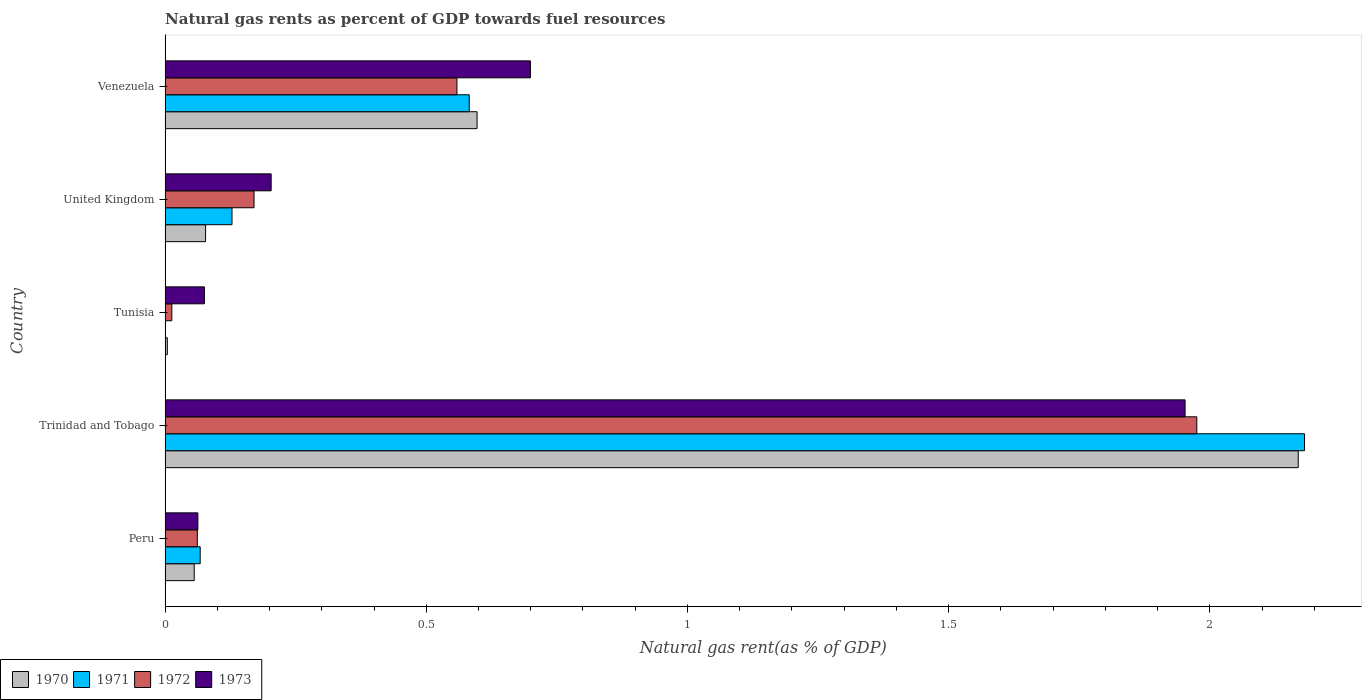Are the number of bars on each tick of the Y-axis equal?
Your answer should be very brief. Yes. What is the label of the 4th group of bars from the top?
Ensure brevity in your answer.  Trinidad and Tobago. In how many cases, is the number of bars for a given country not equal to the number of legend labels?
Provide a short and direct response. 0. What is the natural gas rent in 1971 in Peru?
Keep it short and to the point. 0.07. Across all countries, what is the maximum natural gas rent in 1971?
Your answer should be very brief. 2.18. Across all countries, what is the minimum natural gas rent in 1971?
Give a very brief answer. 0. In which country was the natural gas rent in 1971 maximum?
Provide a short and direct response. Trinidad and Tobago. In which country was the natural gas rent in 1971 minimum?
Your response must be concise. Tunisia. What is the total natural gas rent in 1971 in the graph?
Your answer should be compact. 2.96. What is the difference between the natural gas rent in 1971 in Peru and that in United Kingdom?
Ensure brevity in your answer.  -0.06. What is the difference between the natural gas rent in 1972 in Venezuela and the natural gas rent in 1973 in United Kingdom?
Provide a succinct answer. 0.36. What is the average natural gas rent in 1970 per country?
Provide a short and direct response. 0.58. What is the difference between the natural gas rent in 1973 and natural gas rent in 1970 in Venezuela?
Make the answer very short. 0.1. In how many countries, is the natural gas rent in 1971 greater than 0.9 %?
Give a very brief answer. 1. What is the ratio of the natural gas rent in 1973 in Peru to that in United Kingdom?
Make the answer very short. 0.31. Is the difference between the natural gas rent in 1973 in Peru and United Kingdom greater than the difference between the natural gas rent in 1970 in Peru and United Kingdom?
Provide a short and direct response. No. What is the difference between the highest and the second highest natural gas rent in 1973?
Offer a very short reply. 1.25. What is the difference between the highest and the lowest natural gas rent in 1973?
Your answer should be very brief. 1.89. In how many countries, is the natural gas rent in 1971 greater than the average natural gas rent in 1971 taken over all countries?
Your response must be concise. 1. What does the 1st bar from the top in Peru represents?
Keep it short and to the point. 1973. Is it the case that in every country, the sum of the natural gas rent in 1971 and natural gas rent in 1970 is greater than the natural gas rent in 1972?
Keep it short and to the point. No. How many bars are there?
Make the answer very short. 20. How many countries are there in the graph?
Offer a terse response. 5. What is the difference between two consecutive major ticks on the X-axis?
Ensure brevity in your answer.  0.5. Does the graph contain any zero values?
Your response must be concise. No. What is the title of the graph?
Give a very brief answer. Natural gas rents as percent of GDP towards fuel resources. Does "1973" appear as one of the legend labels in the graph?
Your answer should be very brief. Yes. What is the label or title of the X-axis?
Your answer should be compact. Natural gas rent(as % of GDP). What is the label or title of the Y-axis?
Provide a succinct answer. Country. What is the Natural gas rent(as % of GDP) in 1970 in Peru?
Offer a very short reply. 0.06. What is the Natural gas rent(as % of GDP) of 1971 in Peru?
Provide a succinct answer. 0.07. What is the Natural gas rent(as % of GDP) in 1972 in Peru?
Ensure brevity in your answer.  0.06. What is the Natural gas rent(as % of GDP) of 1973 in Peru?
Your answer should be very brief. 0.06. What is the Natural gas rent(as % of GDP) in 1970 in Trinidad and Tobago?
Give a very brief answer. 2.17. What is the Natural gas rent(as % of GDP) of 1971 in Trinidad and Tobago?
Offer a very short reply. 2.18. What is the Natural gas rent(as % of GDP) in 1972 in Trinidad and Tobago?
Provide a short and direct response. 1.98. What is the Natural gas rent(as % of GDP) in 1973 in Trinidad and Tobago?
Make the answer very short. 1.95. What is the Natural gas rent(as % of GDP) in 1970 in Tunisia?
Give a very brief answer. 0. What is the Natural gas rent(as % of GDP) in 1971 in Tunisia?
Keep it short and to the point. 0. What is the Natural gas rent(as % of GDP) in 1972 in Tunisia?
Make the answer very short. 0.01. What is the Natural gas rent(as % of GDP) of 1973 in Tunisia?
Provide a succinct answer. 0.08. What is the Natural gas rent(as % of GDP) in 1970 in United Kingdom?
Make the answer very short. 0.08. What is the Natural gas rent(as % of GDP) in 1971 in United Kingdom?
Provide a short and direct response. 0.13. What is the Natural gas rent(as % of GDP) in 1972 in United Kingdom?
Provide a succinct answer. 0.17. What is the Natural gas rent(as % of GDP) in 1973 in United Kingdom?
Make the answer very short. 0.2. What is the Natural gas rent(as % of GDP) of 1970 in Venezuela?
Give a very brief answer. 0.6. What is the Natural gas rent(as % of GDP) in 1971 in Venezuela?
Give a very brief answer. 0.58. What is the Natural gas rent(as % of GDP) in 1972 in Venezuela?
Offer a terse response. 0.56. What is the Natural gas rent(as % of GDP) of 1973 in Venezuela?
Offer a very short reply. 0.7. Across all countries, what is the maximum Natural gas rent(as % of GDP) of 1970?
Ensure brevity in your answer.  2.17. Across all countries, what is the maximum Natural gas rent(as % of GDP) of 1971?
Provide a short and direct response. 2.18. Across all countries, what is the maximum Natural gas rent(as % of GDP) in 1972?
Offer a very short reply. 1.98. Across all countries, what is the maximum Natural gas rent(as % of GDP) in 1973?
Your answer should be very brief. 1.95. Across all countries, what is the minimum Natural gas rent(as % of GDP) of 1970?
Make the answer very short. 0. Across all countries, what is the minimum Natural gas rent(as % of GDP) in 1971?
Your response must be concise. 0. Across all countries, what is the minimum Natural gas rent(as % of GDP) of 1972?
Give a very brief answer. 0.01. Across all countries, what is the minimum Natural gas rent(as % of GDP) of 1973?
Keep it short and to the point. 0.06. What is the total Natural gas rent(as % of GDP) in 1970 in the graph?
Give a very brief answer. 2.9. What is the total Natural gas rent(as % of GDP) in 1971 in the graph?
Give a very brief answer. 2.96. What is the total Natural gas rent(as % of GDP) of 1972 in the graph?
Your answer should be compact. 2.78. What is the total Natural gas rent(as % of GDP) of 1973 in the graph?
Make the answer very short. 2.99. What is the difference between the Natural gas rent(as % of GDP) in 1970 in Peru and that in Trinidad and Tobago?
Your answer should be compact. -2.11. What is the difference between the Natural gas rent(as % of GDP) of 1971 in Peru and that in Trinidad and Tobago?
Ensure brevity in your answer.  -2.11. What is the difference between the Natural gas rent(as % of GDP) in 1972 in Peru and that in Trinidad and Tobago?
Your response must be concise. -1.91. What is the difference between the Natural gas rent(as % of GDP) in 1973 in Peru and that in Trinidad and Tobago?
Provide a short and direct response. -1.89. What is the difference between the Natural gas rent(as % of GDP) of 1970 in Peru and that in Tunisia?
Keep it short and to the point. 0.05. What is the difference between the Natural gas rent(as % of GDP) of 1971 in Peru and that in Tunisia?
Provide a short and direct response. 0.07. What is the difference between the Natural gas rent(as % of GDP) in 1972 in Peru and that in Tunisia?
Provide a short and direct response. 0.05. What is the difference between the Natural gas rent(as % of GDP) in 1973 in Peru and that in Tunisia?
Ensure brevity in your answer.  -0.01. What is the difference between the Natural gas rent(as % of GDP) of 1970 in Peru and that in United Kingdom?
Your answer should be compact. -0.02. What is the difference between the Natural gas rent(as % of GDP) in 1971 in Peru and that in United Kingdom?
Provide a short and direct response. -0.06. What is the difference between the Natural gas rent(as % of GDP) of 1972 in Peru and that in United Kingdom?
Provide a succinct answer. -0.11. What is the difference between the Natural gas rent(as % of GDP) of 1973 in Peru and that in United Kingdom?
Provide a short and direct response. -0.14. What is the difference between the Natural gas rent(as % of GDP) of 1970 in Peru and that in Venezuela?
Provide a short and direct response. -0.54. What is the difference between the Natural gas rent(as % of GDP) of 1971 in Peru and that in Venezuela?
Offer a very short reply. -0.52. What is the difference between the Natural gas rent(as % of GDP) in 1972 in Peru and that in Venezuela?
Give a very brief answer. -0.5. What is the difference between the Natural gas rent(as % of GDP) in 1973 in Peru and that in Venezuela?
Provide a short and direct response. -0.64. What is the difference between the Natural gas rent(as % of GDP) in 1970 in Trinidad and Tobago and that in Tunisia?
Make the answer very short. 2.17. What is the difference between the Natural gas rent(as % of GDP) of 1971 in Trinidad and Tobago and that in Tunisia?
Ensure brevity in your answer.  2.18. What is the difference between the Natural gas rent(as % of GDP) in 1972 in Trinidad and Tobago and that in Tunisia?
Ensure brevity in your answer.  1.96. What is the difference between the Natural gas rent(as % of GDP) of 1973 in Trinidad and Tobago and that in Tunisia?
Your response must be concise. 1.88. What is the difference between the Natural gas rent(as % of GDP) in 1970 in Trinidad and Tobago and that in United Kingdom?
Offer a terse response. 2.09. What is the difference between the Natural gas rent(as % of GDP) of 1971 in Trinidad and Tobago and that in United Kingdom?
Your answer should be very brief. 2.05. What is the difference between the Natural gas rent(as % of GDP) in 1972 in Trinidad and Tobago and that in United Kingdom?
Ensure brevity in your answer.  1.8. What is the difference between the Natural gas rent(as % of GDP) in 1973 in Trinidad and Tobago and that in United Kingdom?
Your response must be concise. 1.75. What is the difference between the Natural gas rent(as % of GDP) of 1970 in Trinidad and Tobago and that in Venezuela?
Your answer should be compact. 1.57. What is the difference between the Natural gas rent(as % of GDP) in 1971 in Trinidad and Tobago and that in Venezuela?
Provide a succinct answer. 1.6. What is the difference between the Natural gas rent(as % of GDP) in 1972 in Trinidad and Tobago and that in Venezuela?
Keep it short and to the point. 1.42. What is the difference between the Natural gas rent(as % of GDP) in 1973 in Trinidad and Tobago and that in Venezuela?
Offer a terse response. 1.25. What is the difference between the Natural gas rent(as % of GDP) in 1970 in Tunisia and that in United Kingdom?
Your answer should be compact. -0.07. What is the difference between the Natural gas rent(as % of GDP) of 1971 in Tunisia and that in United Kingdom?
Make the answer very short. -0.13. What is the difference between the Natural gas rent(as % of GDP) in 1972 in Tunisia and that in United Kingdom?
Ensure brevity in your answer.  -0.16. What is the difference between the Natural gas rent(as % of GDP) of 1973 in Tunisia and that in United Kingdom?
Keep it short and to the point. -0.13. What is the difference between the Natural gas rent(as % of GDP) in 1970 in Tunisia and that in Venezuela?
Ensure brevity in your answer.  -0.59. What is the difference between the Natural gas rent(as % of GDP) of 1971 in Tunisia and that in Venezuela?
Your answer should be very brief. -0.58. What is the difference between the Natural gas rent(as % of GDP) in 1972 in Tunisia and that in Venezuela?
Your answer should be very brief. -0.55. What is the difference between the Natural gas rent(as % of GDP) in 1973 in Tunisia and that in Venezuela?
Give a very brief answer. -0.62. What is the difference between the Natural gas rent(as % of GDP) in 1970 in United Kingdom and that in Venezuela?
Offer a very short reply. -0.52. What is the difference between the Natural gas rent(as % of GDP) of 1971 in United Kingdom and that in Venezuela?
Provide a short and direct response. -0.45. What is the difference between the Natural gas rent(as % of GDP) of 1972 in United Kingdom and that in Venezuela?
Offer a very short reply. -0.39. What is the difference between the Natural gas rent(as % of GDP) in 1973 in United Kingdom and that in Venezuela?
Your response must be concise. -0.5. What is the difference between the Natural gas rent(as % of GDP) in 1970 in Peru and the Natural gas rent(as % of GDP) in 1971 in Trinidad and Tobago?
Your response must be concise. -2.13. What is the difference between the Natural gas rent(as % of GDP) of 1970 in Peru and the Natural gas rent(as % of GDP) of 1972 in Trinidad and Tobago?
Your response must be concise. -1.92. What is the difference between the Natural gas rent(as % of GDP) in 1970 in Peru and the Natural gas rent(as % of GDP) in 1973 in Trinidad and Tobago?
Make the answer very short. -1.9. What is the difference between the Natural gas rent(as % of GDP) in 1971 in Peru and the Natural gas rent(as % of GDP) in 1972 in Trinidad and Tobago?
Your answer should be compact. -1.91. What is the difference between the Natural gas rent(as % of GDP) of 1971 in Peru and the Natural gas rent(as % of GDP) of 1973 in Trinidad and Tobago?
Ensure brevity in your answer.  -1.89. What is the difference between the Natural gas rent(as % of GDP) of 1972 in Peru and the Natural gas rent(as % of GDP) of 1973 in Trinidad and Tobago?
Your response must be concise. -1.89. What is the difference between the Natural gas rent(as % of GDP) in 1970 in Peru and the Natural gas rent(as % of GDP) in 1971 in Tunisia?
Provide a succinct answer. 0.06. What is the difference between the Natural gas rent(as % of GDP) in 1970 in Peru and the Natural gas rent(as % of GDP) in 1972 in Tunisia?
Give a very brief answer. 0.04. What is the difference between the Natural gas rent(as % of GDP) in 1970 in Peru and the Natural gas rent(as % of GDP) in 1973 in Tunisia?
Offer a very short reply. -0.02. What is the difference between the Natural gas rent(as % of GDP) in 1971 in Peru and the Natural gas rent(as % of GDP) in 1972 in Tunisia?
Give a very brief answer. 0.05. What is the difference between the Natural gas rent(as % of GDP) of 1971 in Peru and the Natural gas rent(as % of GDP) of 1973 in Tunisia?
Offer a terse response. -0.01. What is the difference between the Natural gas rent(as % of GDP) in 1972 in Peru and the Natural gas rent(as % of GDP) in 1973 in Tunisia?
Ensure brevity in your answer.  -0.01. What is the difference between the Natural gas rent(as % of GDP) of 1970 in Peru and the Natural gas rent(as % of GDP) of 1971 in United Kingdom?
Provide a succinct answer. -0.07. What is the difference between the Natural gas rent(as % of GDP) of 1970 in Peru and the Natural gas rent(as % of GDP) of 1972 in United Kingdom?
Ensure brevity in your answer.  -0.11. What is the difference between the Natural gas rent(as % of GDP) of 1970 in Peru and the Natural gas rent(as % of GDP) of 1973 in United Kingdom?
Provide a short and direct response. -0.15. What is the difference between the Natural gas rent(as % of GDP) of 1971 in Peru and the Natural gas rent(as % of GDP) of 1972 in United Kingdom?
Offer a very short reply. -0.1. What is the difference between the Natural gas rent(as % of GDP) of 1971 in Peru and the Natural gas rent(as % of GDP) of 1973 in United Kingdom?
Offer a very short reply. -0.14. What is the difference between the Natural gas rent(as % of GDP) of 1972 in Peru and the Natural gas rent(as % of GDP) of 1973 in United Kingdom?
Your response must be concise. -0.14. What is the difference between the Natural gas rent(as % of GDP) of 1970 in Peru and the Natural gas rent(as % of GDP) of 1971 in Venezuela?
Your response must be concise. -0.53. What is the difference between the Natural gas rent(as % of GDP) of 1970 in Peru and the Natural gas rent(as % of GDP) of 1972 in Venezuela?
Keep it short and to the point. -0.5. What is the difference between the Natural gas rent(as % of GDP) in 1970 in Peru and the Natural gas rent(as % of GDP) in 1973 in Venezuela?
Offer a terse response. -0.64. What is the difference between the Natural gas rent(as % of GDP) of 1971 in Peru and the Natural gas rent(as % of GDP) of 1972 in Venezuela?
Your answer should be compact. -0.49. What is the difference between the Natural gas rent(as % of GDP) in 1971 in Peru and the Natural gas rent(as % of GDP) in 1973 in Venezuela?
Your answer should be very brief. -0.63. What is the difference between the Natural gas rent(as % of GDP) of 1972 in Peru and the Natural gas rent(as % of GDP) of 1973 in Venezuela?
Your answer should be very brief. -0.64. What is the difference between the Natural gas rent(as % of GDP) of 1970 in Trinidad and Tobago and the Natural gas rent(as % of GDP) of 1971 in Tunisia?
Your response must be concise. 2.17. What is the difference between the Natural gas rent(as % of GDP) of 1970 in Trinidad and Tobago and the Natural gas rent(as % of GDP) of 1972 in Tunisia?
Offer a very short reply. 2.16. What is the difference between the Natural gas rent(as % of GDP) of 1970 in Trinidad and Tobago and the Natural gas rent(as % of GDP) of 1973 in Tunisia?
Ensure brevity in your answer.  2.09. What is the difference between the Natural gas rent(as % of GDP) of 1971 in Trinidad and Tobago and the Natural gas rent(as % of GDP) of 1972 in Tunisia?
Offer a very short reply. 2.17. What is the difference between the Natural gas rent(as % of GDP) in 1971 in Trinidad and Tobago and the Natural gas rent(as % of GDP) in 1973 in Tunisia?
Your answer should be very brief. 2.11. What is the difference between the Natural gas rent(as % of GDP) in 1972 in Trinidad and Tobago and the Natural gas rent(as % of GDP) in 1973 in Tunisia?
Your answer should be compact. 1.9. What is the difference between the Natural gas rent(as % of GDP) of 1970 in Trinidad and Tobago and the Natural gas rent(as % of GDP) of 1971 in United Kingdom?
Ensure brevity in your answer.  2.04. What is the difference between the Natural gas rent(as % of GDP) of 1970 in Trinidad and Tobago and the Natural gas rent(as % of GDP) of 1972 in United Kingdom?
Offer a terse response. 2. What is the difference between the Natural gas rent(as % of GDP) of 1970 in Trinidad and Tobago and the Natural gas rent(as % of GDP) of 1973 in United Kingdom?
Ensure brevity in your answer.  1.97. What is the difference between the Natural gas rent(as % of GDP) of 1971 in Trinidad and Tobago and the Natural gas rent(as % of GDP) of 1972 in United Kingdom?
Provide a succinct answer. 2.01. What is the difference between the Natural gas rent(as % of GDP) in 1971 in Trinidad and Tobago and the Natural gas rent(as % of GDP) in 1973 in United Kingdom?
Offer a very short reply. 1.98. What is the difference between the Natural gas rent(as % of GDP) of 1972 in Trinidad and Tobago and the Natural gas rent(as % of GDP) of 1973 in United Kingdom?
Keep it short and to the point. 1.77. What is the difference between the Natural gas rent(as % of GDP) of 1970 in Trinidad and Tobago and the Natural gas rent(as % of GDP) of 1971 in Venezuela?
Give a very brief answer. 1.59. What is the difference between the Natural gas rent(as % of GDP) in 1970 in Trinidad and Tobago and the Natural gas rent(as % of GDP) in 1972 in Venezuela?
Your answer should be very brief. 1.61. What is the difference between the Natural gas rent(as % of GDP) of 1970 in Trinidad and Tobago and the Natural gas rent(as % of GDP) of 1973 in Venezuela?
Provide a short and direct response. 1.47. What is the difference between the Natural gas rent(as % of GDP) in 1971 in Trinidad and Tobago and the Natural gas rent(as % of GDP) in 1972 in Venezuela?
Ensure brevity in your answer.  1.62. What is the difference between the Natural gas rent(as % of GDP) in 1971 in Trinidad and Tobago and the Natural gas rent(as % of GDP) in 1973 in Venezuela?
Your answer should be very brief. 1.48. What is the difference between the Natural gas rent(as % of GDP) in 1972 in Trinidad and Tobago and the Natural gas rent(as % of GDP) in 1973 in Venezuela?
Your answer should be compact. 1.28. What is the difference between the Natural gas rent(as % of GDP) in 1970 in Tunisia and the Natural gas rent(as % of GDP) in 1971 in United Kingdom?
Your answer should be very brief. -0.12. What is the difference between the Natural gas rent(as % of GDP) of 1970 in Tunisia and the Natural gas rent(as % of GDP) of 1972 in United Kingdom?
Provide a short and direct response. -0.17. What is the difference between the Natural gas rent(as % of GDP) of 1970 in Tunisia and the Natural gas rent(as % of GDP) of 1973 in United Kingdom?
Ensure brevity in your answer.  -0.2. What is the difference between the Natural gas rent(as % of GDP) of 1971 in Tunisia and the Natural gas rent(as % of GDP) of 1972 in United Kingdom?
Your answer should be very brief. -0.17. What is the difference between the Natural gas rent(as % of GDP) of 1971 in Tunisia and the Natural gas rent(as % of GDP) of 1973 in United Kingdom?
Your answer should be very brief. -0.2. What is the difference between the Natural gas rent(as % of GDP) in 1972 in Tunisia and the Natural gas rent(as % of GDP) in 1973 in United Kingdom?
Keep it short and to the point. -0.19. What is the difference between the Natural gas rent(as % of GDP) in 1970 in Tunisia and the Natural gas rent(as % of GDP) in 1971 in Venezuela?
Provide a succinct answer. -0.58. What is the difference between the Natural gas rent(as % of GDP) in 1970 in Tunisia and the Natural gas rent(as % of GDP) in 1972 in Venezuela?
Your answer should be compact. -0.55. What is the difference between the Natural gas rent(as % of GDP) of 1970 in Tunisia and the Natural gas rent(as % of GDP) of 1973 in Venezuela?
Your answer should be very brief. -0.7. What is the difference between the Natural gas rent(as % of GDP) in 1971 in Tunisia and the Natural gas rent(as % of GDP) in 1972 in Venezuela?
Your answer should be compact. -0.56. What is the difference between the Natural gas rent(as % of GDP) in 1971 in Tunisia and the Natural gas rent(as % of GDP) in 1973 in Venezuela?
Your answer should be very brief. -0.7. What is the difference between the Natural gas rent(as % of GDP) in 1972 in Tunisia and the Natural gas rent(as % of GDP) in 1973 in Venezuela?
Give a very brief answer. -0.69. What is the difference between the Natural gas rent(as % of GDP) in 1970 in United Kingdom and the Natural gas rent(as % of GDP) in 1971 in Venezuela?
Ensure brevity in your answer.  -0.5. What is the difference between the Natural gas rent(as % of GDP) in 1970 in United Kingdom and the Natural gas rent(as % of GDP) in 1972 in Venezuela?
Your response must be concise. -0.48. What is the difference between the Natural gas rent(as % of GDP) in 1970 in United Kingdom and the Natural gas rent(as % of GDP) in 1973 in Venezuela?
Your answer should be compact. -0.62. What is the difference between the Natural gas rent(as % of GDP) of 1971 in United Kingdom and the Natural gas rent(as % of GDP) of 1972 in Venezuela?
Provide a short and direct response. -0.43. What is the difference between the Natural gas rent(as % of GDP) of 1971 in United Kingdom and the Natural gas rent(as % of GDP) of 1973 in Venezuela?
Provide a succinct answer. -0.57. What is the difference between the Natural gas rent(as % of GDP) in 1972 in United Kingdom and the Natural gas rent(as % of GDP) in 1973 in Venezuela?
Your answer should be very brief. -0.53. What is the average Natural gas rent(as % of GDP) of 1970 per country?
Make the answer very short. 0.58. What is the average Natural gas rent(as % of GDP) in 1971 per country?
Your answer should be very brief. 0.59. What is the average Natural gas rent(as % of GDP) in 1972 per country?
Provide a short and direct response. 0.56. What is the average Natural gas rent(as % of GDP) in 1973 per country?
Give a very brief answer. 0.6. What is the difference between the Natural gas rent(as % of GDP) in 1970 and Natural gas rent(as % of GDP) in 1971 in Peru?
Ensure brevity in your answer.  -0.01. What is the difference between the Natural gas rent(as % of GDP) of 1970 and Natural gas rent(as % of GDP) of 1972 in Peru?
Your answer should be very brief. -0.01. What is the difference between the Natural gas rent(as % of GDP) in 1970 and Natural gas rent(as % of GDP) in 1973 in Peru?
Your answer should be compact. -0.01. What is the difference between the Natural gas rent(as % of GDP) in 1971 and Natural gas rent(as % of GDP) in 1972 in Peru?
Provide a short and direct response. 0.01. What is the difference between the Natural gas rent(as % of GDP) in 1971 and Natural gas rent(as % of GDP) in 1973 in Peru?
Your answer should be compact. 0. What is the difference between the Natural gas rent(as % of GDP) of 1972 and Natural gas rent(as % of GDP) of 1973 in Peru?
Ensure brevity in your answer.  -0. What is the difference between the Natural gas rent(as % of GDP) of 1970 and Natural gas rent(as % of GDP) of 1971 in Trinidad and Tobago?
Give a very brief answer. -0.01. What is the difference between the Natural gas rent(as % of GDP) of 1970 and Natural gas rent(as % of GDP) of 1972 in Trinidad and Tobago?
Give a very brief answer. 0.19. What is the difference between the Natural gas rent(as % of GDP) of 1970 and Natural gas rent(as % of GDP) of 1973 in Trinidad and Tobago?
Provide a succinct answer. 0.22. What is the difference between the Natural gas rent(as % of GDP) of 1971 and Natural gas rent(as % of GDP) of 1972 in Trinidad and Tobago?
Give a very brief answer. 0.21. What is the difference between the Natural gas rent(as % of GDP) in 1971 and Natural gas rent(as % of GDP) in 1973 in Trinidad and Tobago?
Give a very brief answer. 0.23. What is the difference between the Natural gas rent(as % of GDP) in 1972 and Natural gas rent(as % of GDP) in 1973 in Trinidad and Tobago?
Make the answer very short. 0.02. What is the difference between the Natural gas rent(as % of GDP) in 1970 and Natural gas rent(as % of GDP) in 1971 in Tunisia?
Ensure brevity in your answer.  0. What is the difference between the Natural gas rent(as % of GDP) in 1970 and Natural gas rent(as % of GDP) in 1972 in Tunisia?
Offer a very short reply. -0.01. What is the difference between the Natural gas rent(as % of GDP) in 1970 and Natural gas rent(as % of GDP) in 1973 in Tunisia?
Make the answer very short. -0.07. What is the difference between the Natural gas rent(as % of GDP) in 1971 and Natural gas rent(as % of GDP) in 1972 in Tunisia?
Offer a terse response. -0.01. What is the difference between the Natural gas rent(as % of GDP) in 1971 and Natural gas rent(as % of GDP) in 1973 in Tunisia?
Offer a very short reply. -0.07. What is the difference between the Natural gas rent(as % of GDP) of 1972 and Natural gas rent(as % of GDP) of 1973 in Tunisia?
Your answer should be very brief. -0.06. What is the difference between the Natural gas rent(as % of GDP) of 1970 and Natural gas rent(as % of GDP) of 1971 in United Kingdom?
Ensure brevity in your answer.  -0.05. What is the difference between the Natural gas rent(as % of GDP) in 1970 and Natural gas rent(as % of GDP) in 1972 in United Kingdom?
Provide a succinct answer. -0.09. What is the difference between the Natural gas rent(as % of GDP) of 1970 and Natural gas rent(as % of GDP) of 1973 in United Kingdom?
Your response must be concise. -0.13. What is the difference between the Natural gas rent(as % of GDP) of 1971 and Natural gas rent(as % of GDP) of 1972 in United Kingdom?
Your response must be concise. -0.04. What is the difference between the Natural gas rent(as % of GDP) of 1971 and Natural gas rent(as % of GDP) of 1973 in United Kingdom?
Offer a terse response. -0.07. What is the difference between the Natural gas rent(as % of GDP) of 1972 and Natural gas rent(as % of GDP) of 1973 in United Kingdom?
Your answer should be compact. -0.03. What is the difference between the Natural gas rent(as % of GDP) of 1970 and Natural gas rent(as % of GDP) of 1971 in Venezuela?
Your response must be concise. 0.01. What is the difference between the Natural gas rent(as % of GDP) in 1970 and Natural gas rent(as % of GDP) in 1972 in Venezuela?
Keep it short and to the point. 0.04. What is the difference between the Natural gas rent(as % of GDP) of 1970 and Natural gas rent(as % of GDP) of 1973 in Venezuela?
Offer a very short reply. -0.1. What is the difference between the Natural gas rent(as % of GDP) in 1971 and Natural gas rent(as % of GDP) in 1972 in Venezuela?
Your response must be concise. 0.02. What is the difference between the Natural gas rent(as % of GDP) in 1971 and Natural gas rent(as % of GDP) in 1973 in Venezuela?
Offer a very short reply. -0.12. What is the difference between the Natural gas rent(as % of GDP) in 1972 and Natural gas rent(as % of GDP) in 1973 in Venezuela?
Give a very brief answer. -0.14. What is the ratio of the Natural gas rent(as % of GDP) in 1970 in Peru to that in Trinidad and Tobago?
Make the answer very short. 0.03. What is the ratio of the Natural gas rent(as % of GDP) in 1971 in Peru to that in Trinidad and Tobago?
Keep it short and to the point. 0.03. What is the ratio of the Natural gas rent(as % of GDP) of 1972 in Peru to that in Trinidad and Tobago?
Ensure brevity in your answer.  0.03. What is the ratio of the Natural gas rent(as % of GDP) of 1973 in Peru to that in Trinidad and Tobago?
Your response must be concise. 0.03. What is the ratio of the Natural gas rent(as % of GDP) in 1970 in Peru to that in Tunisia?
Offer a very short reply. 13.15. What is the ratio of the Natural gas rent(as % of GDP) of 1971 in Peru to that in Tunisia?
Provide a succinct answer. 90.55. What is the ratio of the Natural gas rent(as % of GDP) of 1972 in Peru to that in Tunisia?
Give a very brief answer. 4.79. What is the ratio of the Natural gas rent(as % of GDP) of 1973 in Peru to that in Tunisia?
Provide a short and direct response. 0.83. What is the ratio of the Natural gas rent(as % of GDP) in 1970 in Peru to that in United Kingdom?
Your answer should be very brief. 0.72. What is the ratio of the Natural gas rent(as % of GDP) of 1971 in Peru to that in United Kingdom?
Ensure brevity in your answer.  0.52. What is the ratio of the Natural gas rent(as % of GDP) in 1972 in Peru to that in United Kingdom?
Keep it short and to the point. 0.36. What is the ratio of the Natural gas rent(as % of GDP) of 1973 in Peru to that in United Kingdom?
Provide a succinct answer. 0.31. What is the ratio of the Natural gas rent(as % of GDP) of 1970 in Peru to that in Venezuela?
Provide a short and direct response. 0.09. What is the ratio of the Natural gas rent(as % of GDP) in 1971 in Peru to that in Venezuela?
Your response must be concise. 0.12. What is the ratio of the Natural gas rent(as % of GDP) in 1972 in Peru to that in Venezuela?
Ensure brevity in your answer.  0.11. What is the ratio of the Natural gas rent(as % of GDP) in 1973 in Peru to that in Venezuela?
Offer a very short reply. 0.09. What is the ratio of the Natural gas rent(as % of GDP) of 1970 in Trinidad and Tobago to that in Tunisia?
Provide a succinct answer. 511.49. What is the ratio of the Natural gas rent(as % of GDP) in 1971 in Trinidad and Tobago to that in Tunisia?
Your response must be concise. 2940.6. What is the ratio of the Natural gas rent(as % of GDP) in 1972 in Trinidad and Tobago to that in Tunisia?
Provide a succinct answer. 153.39. What is the ratio of the Natural gas rent(as % of GDP) in 1973 in Trinidad and Tobago to that in Tunisia?
Your answer should be compact. 25.94. What is the ratio of the Natural gas rent(as % of GDP) in 1970 in Trinidad and Tobago to that in United Kingdom?
Your answer should be very brief. 27.99. What is the ratio of the Natural gas rent(as % of GDP) in 1971 in Trinidad and Tobago to that in United Kingdom?
Provide a short and direct response. 17.03. What is the ratio of the Natural gas rent(as % of GDP) in 1972 in Trinidad and Tobago to that in United Kingdom?
Keep it short and to the point. 11.6. What is the ratio of the Natural gas rent(as % of GDP) of 1973 in Trinidad and Tobago to that in United Kingdom?
Provide a short and direct response. 9.62. What is the ratio of the Natural gas rent(as % of GDP) of 1970 in Trinidad and Tobago to that in Venezuela?
Give a very brief answer. 3.63. What is the ratio of the Natural gas rent(as % of GDP) in 1971 in Trinidad and Tobago to that in Venezuela?
Provide a short and direct response. 3.75. What is the ratio of the Natural gas rent(as % of GDP) in 1972 in Trinidad and Tobago to that in Venezuela?
Ensure brevity in your answer.  3.54. What is the ratio of the Natural gas rent(as % of GDP) in 1973 in Trinidad and Tobago to that in Venezuela?
Offer a terse response. 2.79. What is the ratio of the Natural gas rent(as % of GDP) in 1970 in Tunisia to that in United Kingdom?
Your answer should be very brief. 0.05. What is the ratio of the Natural gas rent(as % of GDP) of 1971 in Tunisia to that in United Kingdom?
Offer a very short reply. 0.01. What is the ratio of the Natural gas rent(as % of GDP) of 1972 in Tunisia to that in United Kingdom?
Provide a succinct answer. 0.08. What is the ratio of the Natural gas rent(as % of GDP) of 1973 in Tunisia to that in United Kingdom?
Offer a very short reply. 0.37. What is the ratio of the Natural gas rent(as % of GDP) of 1970 in Tunisia to that in Venezuela?
Your answer should be very brief. 0.01. What is the ratio of the Natural gas rent(as % of GDP) of 1971 in Tunisia to that in Venezuela?
Your answer should be compact. 0. What is the ratio of the Natural gas rent(as % of GDP) of 1972 in Tunisia to that in Venezuela?
Ensure brevity in your answer.  0.02. What is the ratio of the Natural gas rent(as % of GDP) in 1973 in Tunisia to that in Venezuela?
Offer a terse response. 0.11. What is the ratio of the Natural gas rent(as % of GDP) in 1970 in United Kingdom to that in Venezuela?
Your answer should be compact. 0.13. What is the ratio of the Natural gas rent(as % of GDP) of 1971 in United Kingdom to that in Venezuela?
Make the answer very short. 0.22. What is the ratio of the Natural gas rent(as % of GDP) in 1972 in United Kingdom to that in Venezuela?
Your response must be concise. 0.3. What is the ratio of the Natural gas rent(as % of GDP) of 1973 in United Kingdom to that in Venezuela?
Your response must be concise. 0.29. What is the difference between the highest and the second highest Natural gas rent(as % of GDP) of 1970?
Make the answer very short. 1.57. What is the difference between the highest and the second highest Natural gas rent(as % of GDP) of 1971?
Your answer should be compact. 1.6. What is the difference between the highest and the second highest Natural gas rent(as % of GDP) in 1972?
Provide a succinct answer. 1.42. What is the difference between the highest and the second highest Natural gas rent(as % of GDP) in 1973?
Make the answer very short. 1.25. What is the difference between the highest and the lowest Natural gas rent(as % of GDP) in 1970?
Offer a terse response. 2.17. What is the difference between the highest and the lowest Natural gas rent(as % of GDP) of 1971?
Offer a very short reply. 2.18. What is the difference between the highest and the lowest Natural gas rent(as % of GDP) in 1972?
Provide a short and direct response. 1.96. What is the difference between the highest and the lowest Natural gas rent(as % of GDP) in 1973?
Ensure brevity in your answer.  1.89. 